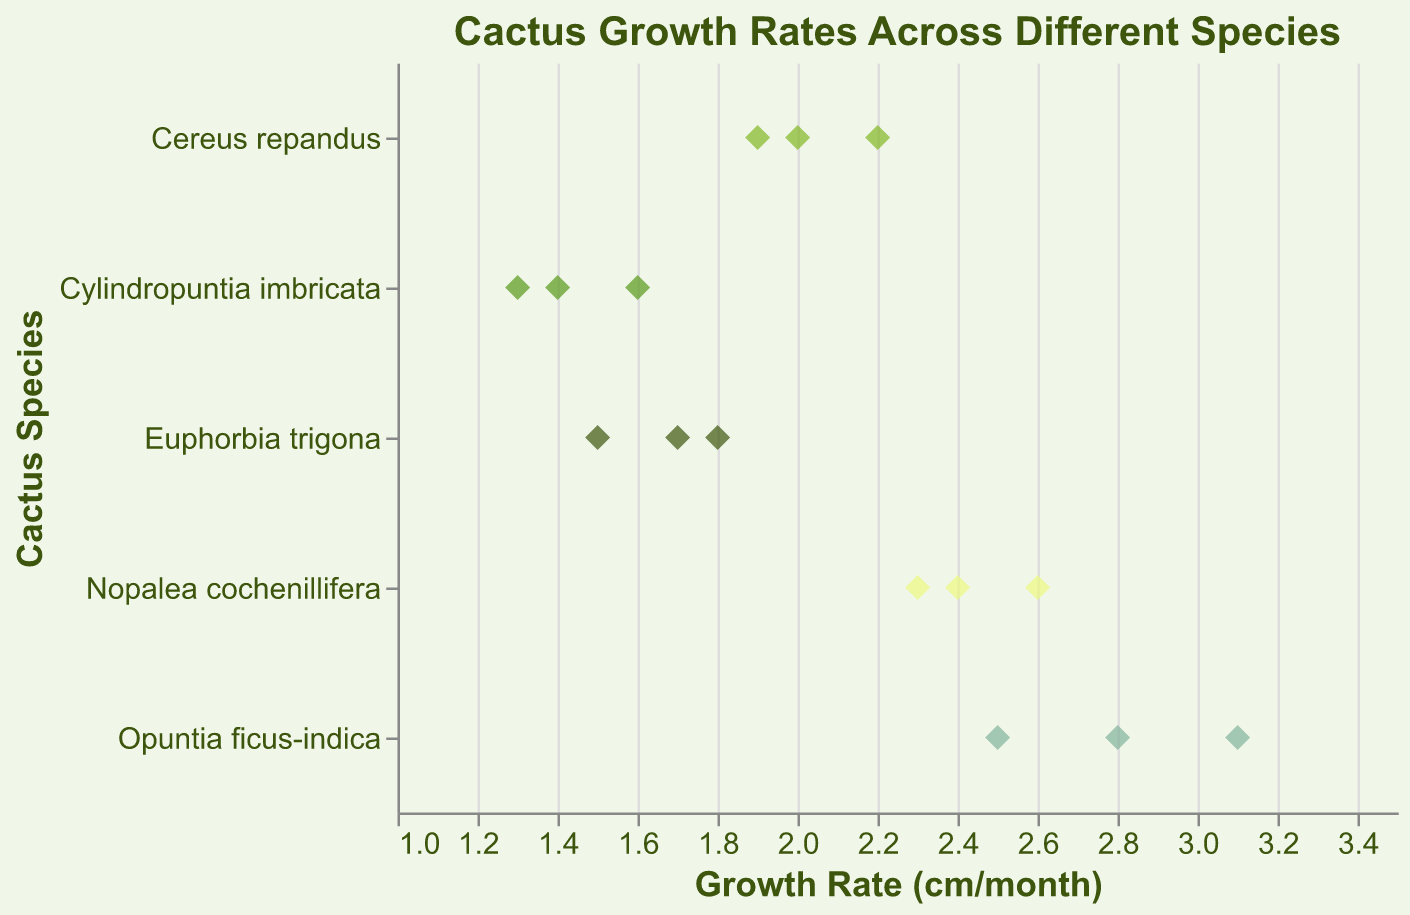What is the growth rate range for Opuntia ficus-indica? The growth rates for Opuntia ficus-indica are 2.5, 3.1, and 2.8 cm per month. The smallest value is 2.5 and the largest is 3.1.
Answer: 2.5 to 3.1 cm per month What color represents the species Cereus repandus in the plot? Cereus repandus is represented with a medium green color in the plot.
Answer: Medium green Which species shows the highest maximum growth rate? Opuntia ficus-indica has the highest observed maximum growth rate of 3.1 cm per month.
Answer: Opuntia ficus-indica How many data points are plotted for each species? Each species has 3 data points as indicated by the data table, showing three entries for each species.
Answer: 3 points per species Which species has the lowest average growth rate? Cylindropuntia imbricata has growth rates of 1.3, 1.6, and 1.4 cm per month. The average growth rate is (1.3+1.6+1.4)/3 = 1.43 cm per month. This is the lowest among all species.
Answer: Cylindropuntia imbricata What is the mean growth rate for Euphorbia trigona? The growth rates for Euphorbia trigona are 1.7, 1.5, and 1.8 cm per month. The mean growth rate is (1.7 + 1.5 + 1.8) / 3 = 1.67 cm per month.
Answer: 1.67 cm per month Which species exhibits the narrowest range of growth rates? Euphorbia trigona has growth rates of 1.7, 1.5, and 1.8 cm per month, yielding a range of 1.8 - 1.5 = 0.3 cm per month. This is the smallest range among all species.
Answer: Euphorbia trigona How does the average growth rate of Nopalea cochenillifera compare to that of Cereus repandus? The growth rates for Nopalea cochenillifera are 2.3, 2.6, and 2.4 cm per month, having an average of (2.3 + 2.6 + 2.4) / 3 = 2.43 cm per month. Cereus repandus has rates of 1.9, 2.2, and 2.0, leading to an average of (1.9 + 2.2 + 2.0) / 3 = 2.03 cm per month. Thus, Nopalea cochenillifera's average is higher.
Answer: Nopalea cochenillifera's average is higher What species has its growth rate entirely below 2 cm per month? Cylindropuntia imbricata has growth rates of 1.3, 1.6, and 1.4 cm per month, all below 2 cm per month.
Answer: Cylindropuntia imbricata 